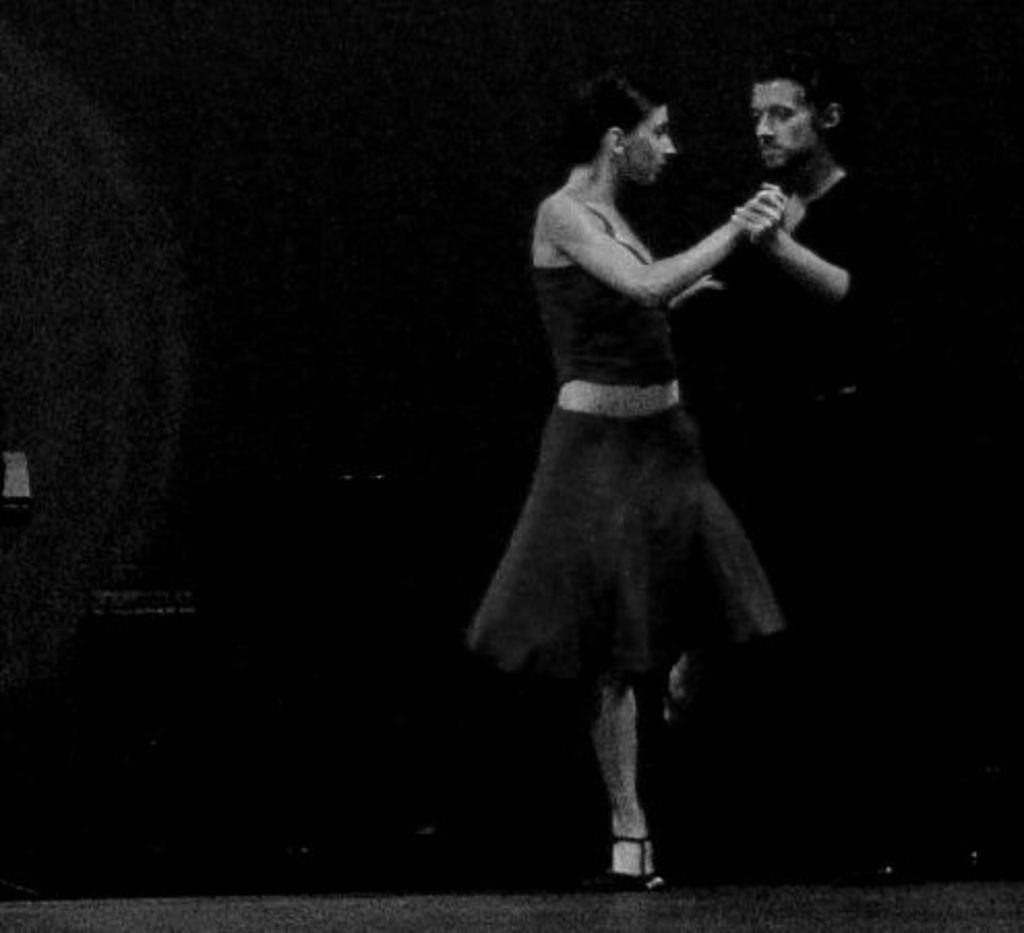Who are the people in the image? There is a man and a woman in the image. What are the man and woman doing in the image? The man and woman are dancing in the image. How are they interacting with each other while dancing? They are holding hands while dancing. What color are the clothes they are wearing? They are wearing black color dress. What type of bird can be seen flying in the image? There is no bird present in the image; it features a man and a woman dancing while holding hands. 